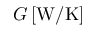Convert formula to latex. <formula><loc_0><loc_0><loc_500><loc_500>G \, [ W / K ]</formula> 